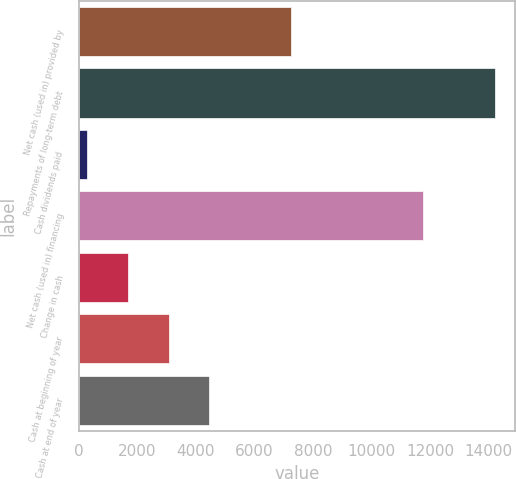<chart> <loc_0><loc_0><loc_500><loc_500><bar_chart><fcel>Net cash (used in) provided by<fcel>Repayments of long-term debt<fcel>Cash dividends paid<fcel>Net cash (used in) financing<fcel>Change in cash<fcel>Cash at beginning of year<fcel>Cash at end of year<nl><fcel>7255.3<fcel>14197<fcel>294<fcel>11758<fcel>1684.3<fcel>3074.6<fcel>4464.9<nl></chart> 